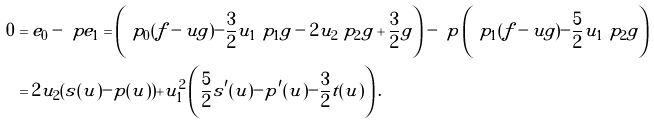Convert formula to latex. <formula><loc_0><loc_0><loc_500><loc_500>0 & = e _ { 0 } - \ p e _ { 1 } = \left ( \ p _ { 0 } ( f - u g ) - \frac { 3 } { 2 } u _ { 1 } \ p _ { 1 } g - 2 u _ { 2 } \ p _ { 2 } g + \frac { 3 } { 2 } g \right ) - \ p \left ( \ p _ { 1 } ( f - u g ) - \frac { 5 } { 2 } u _ { 1 } \ p _ { 2 } g \right ) \\ & = 2 u _ { 2 } ( s ( u ) - p ( u ) ) + u _ { 1 } ^ { 2 } \left ( \frac { 5 } { 2 } s ^ { \prime } ( u ) - p ^ { \prime } ( u ) - \frac { 3 } { 2 } t ( u ) \right ) .</formula> 